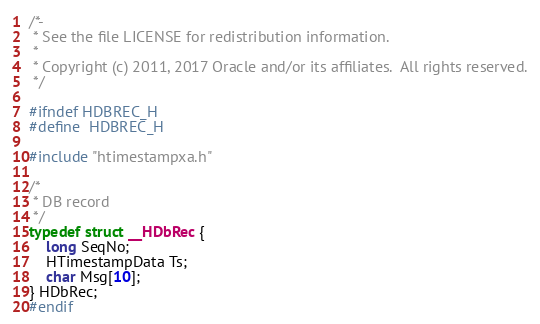<code> <loc_0><loc_0><loc_500><loc_500><_C_>/*-
 * See the file LICENSE for redistribution information.
 *
 * Copyright (c) 2011, 2017 Oracle and/or its affiliates.  All rights reserved.
 */

#ifndef HDBREC_H
#define	HDBREC_H

#include "htimestampxa.h"

/*
 * DB record
 */
typedef struct __HDbRec {
	long SeqNo;
	HTimestampData Ts;
	char Msg[10];
} HDbRec;
#endif
</code> 